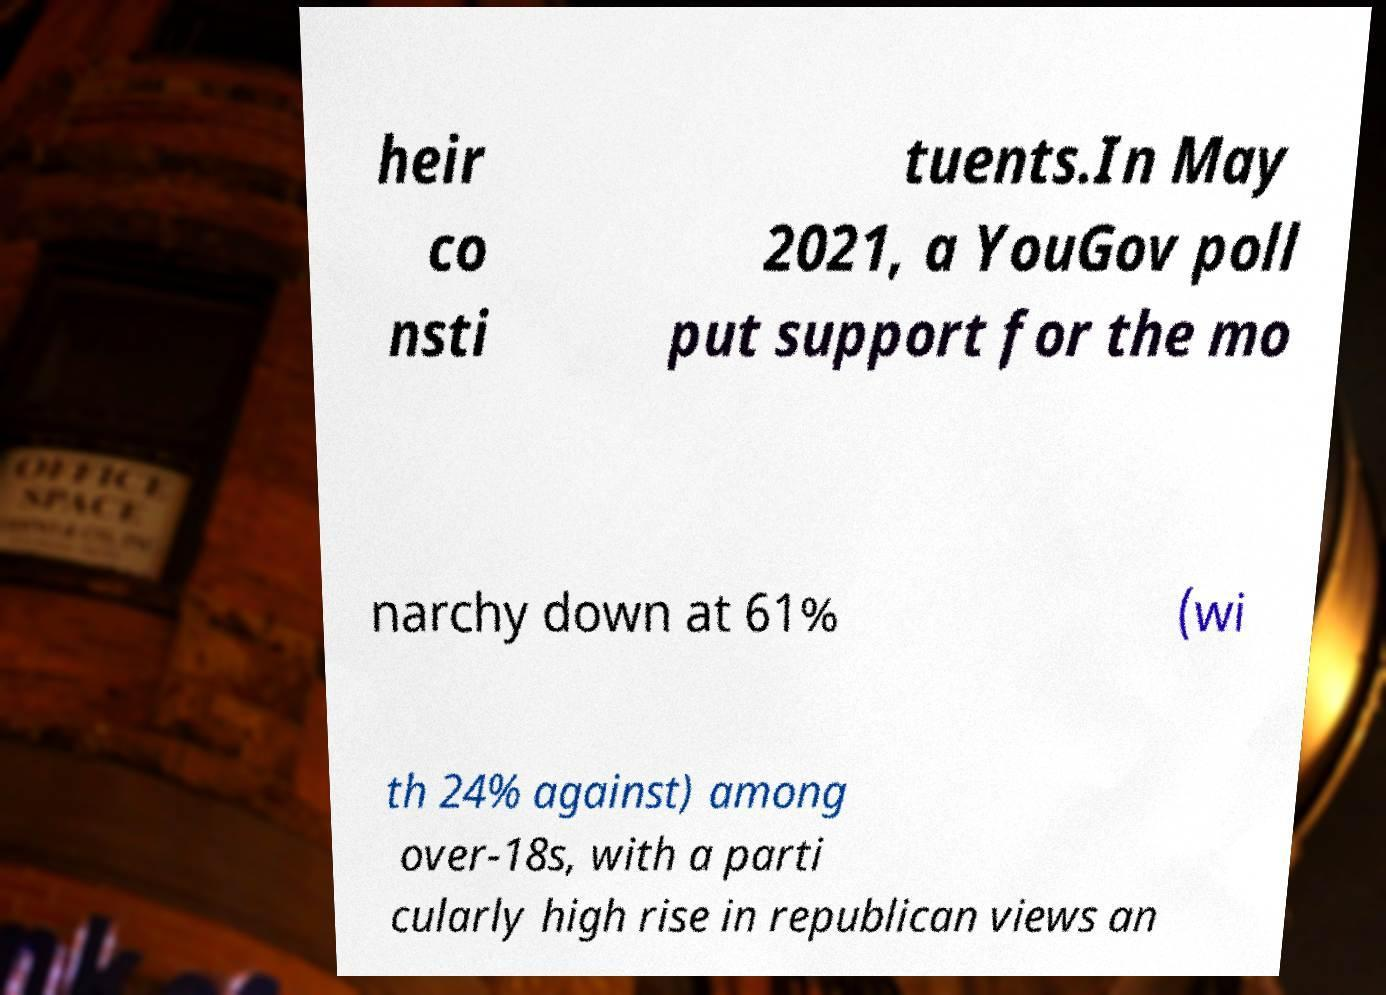I need the written content from this picture converted into text. Can you do that? heir co nsti tuents.In May 2021, a YouGov poll put support for the mo narchy down at 61% (wi th 24% against) among over-18s, with a parti cularly high rise in republican views an 